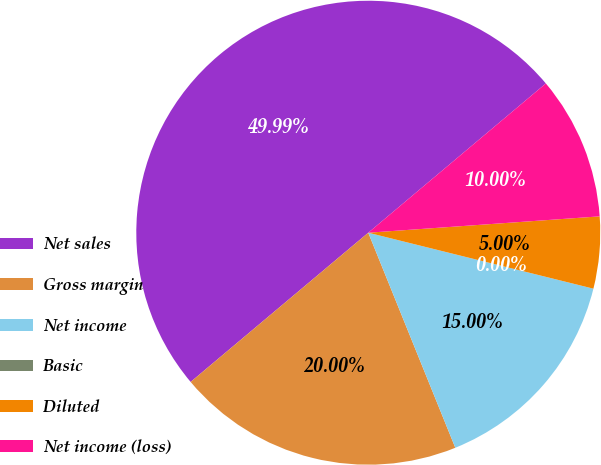Convert chart. <chart><loc_0><loc_0><loc_500><loc_500><pie_chart><fcel>Net sales<fcel>Gross margin<fcel>Net income<fcel>Basic<fcel>Diluted<fcel>Net income (loss)<nl><fcel>49.99%<fcel>20.0%<fcel>15.0%<fcel>0.0%<fcel>5.0%<fcel>10.0%<nl></chart> 